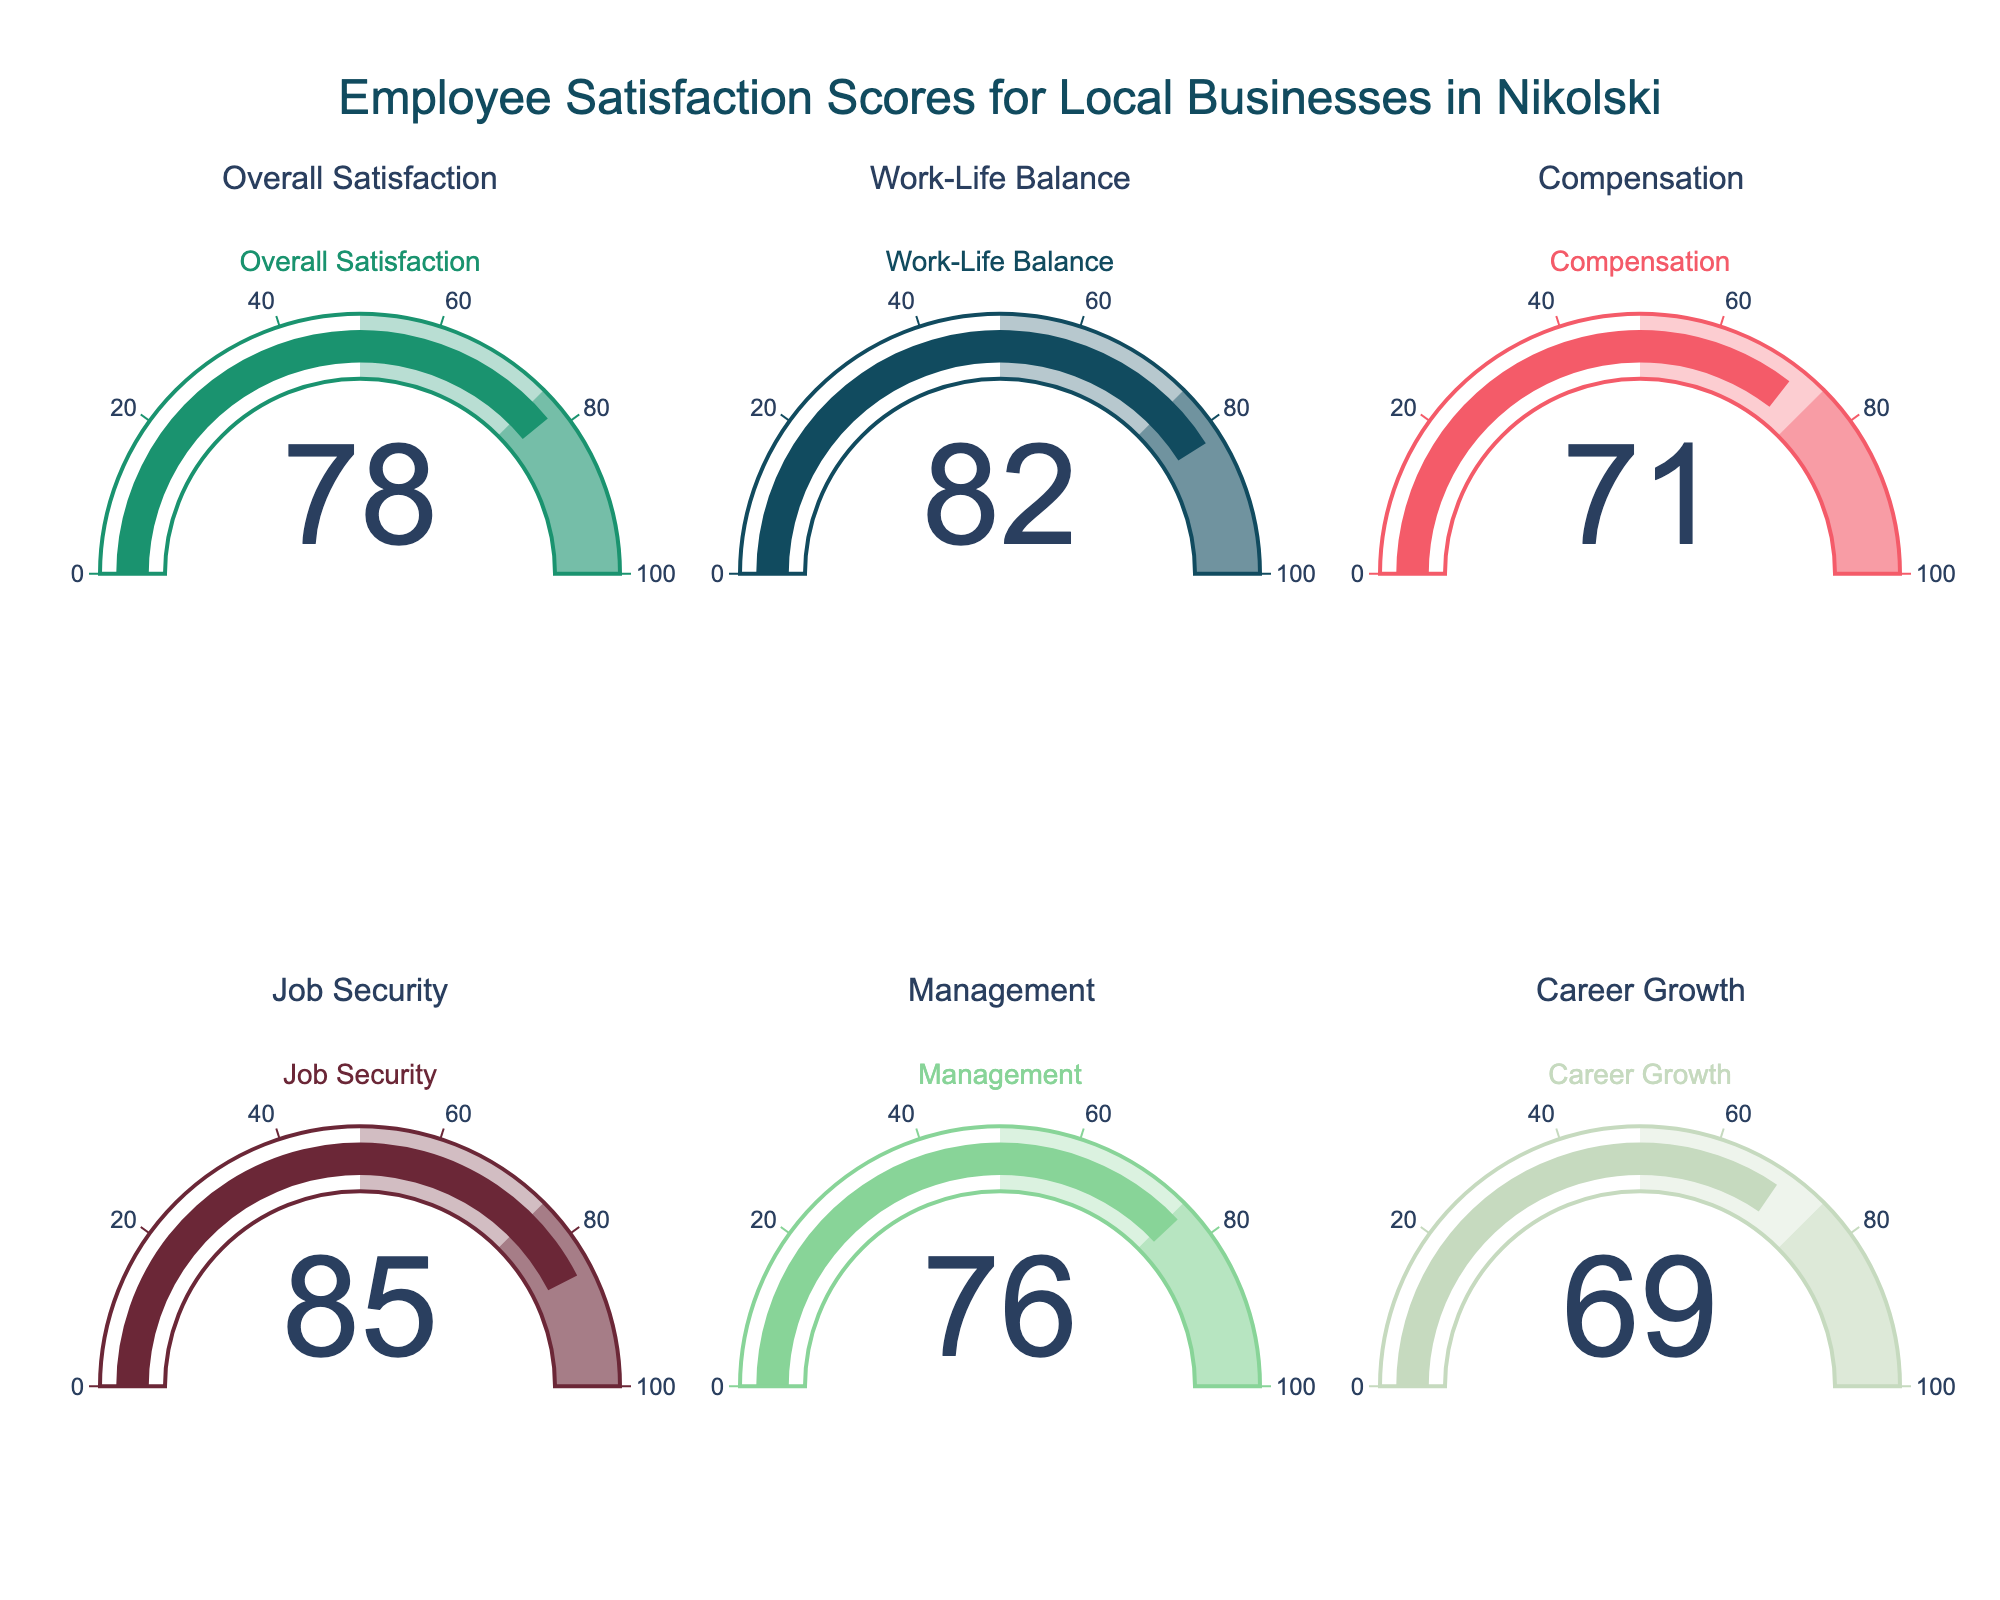What's the overall employee satisfaction score? The overall satisfaction score is displayed on one of the gauges.
Answer: 78 Which category has the highest score? Compare each category's score shown on the gauges to identify the highest one.
Answer: Job Security What is the difference between the score for Work-Life Balance and Compensation? Subtract the Compensation score from the Work-Life Balance score: 82 - 71.
Answer: 11 Which categories have scores above 80? Check each gauge to see which scores are above 80.
Answer: Work-Life Balance, Job Security On average, how satisfied are employees with Compensation and Career Growth? Add the Compensation (71) and Career Growth (69) scores and divide by 2: (71 + 69) / 2.
Answer: 70 Is the score for Management higher than the Overall Satisfaction score? Compare the scores for Management (76) and Overall Satisfaction (78).
Answer: No Which category has the lowest score? Compare all the categories' scores and identify the lowest one.
Answer: Career Growth What is the score range displayed on each gauge? Each gauge shows a score range from 0 to 100.
Answer: 0 to 100 What is the average score of all categories? Sum all the category scores and divide by the number of categories: (78 + 82 + 71 + 85 + 76 + 69) / 6.
Answer: 76.83 Which category has a score closest to 75? Identify the category whose score is nearest to 75.
Answer: Management 